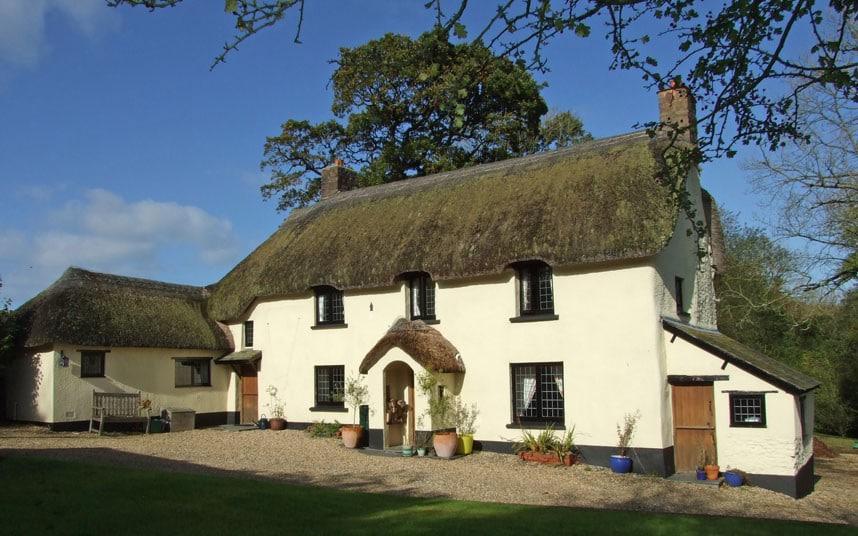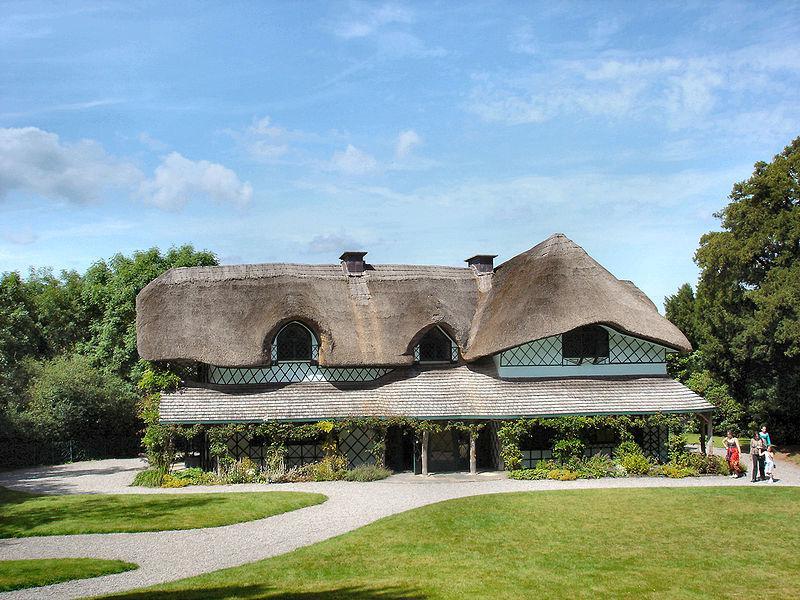The first image is the image on the left, the second image is the image on the right. Assess this claim about the two images: "At least one of the 2 houses has a wooden fence around it.". Correct or not? Answer yes or no. No. The first image is the image on the left, the second image is the image on the right. Considering the images on both sides, is "One of the houses has two chimneys, one on each end of the roof line." valid? Answer yes or no. Yes. 